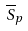<formula> <loc_0><loc_0><loc_500><loc_500>\overline { S } _ { p }</formula> 